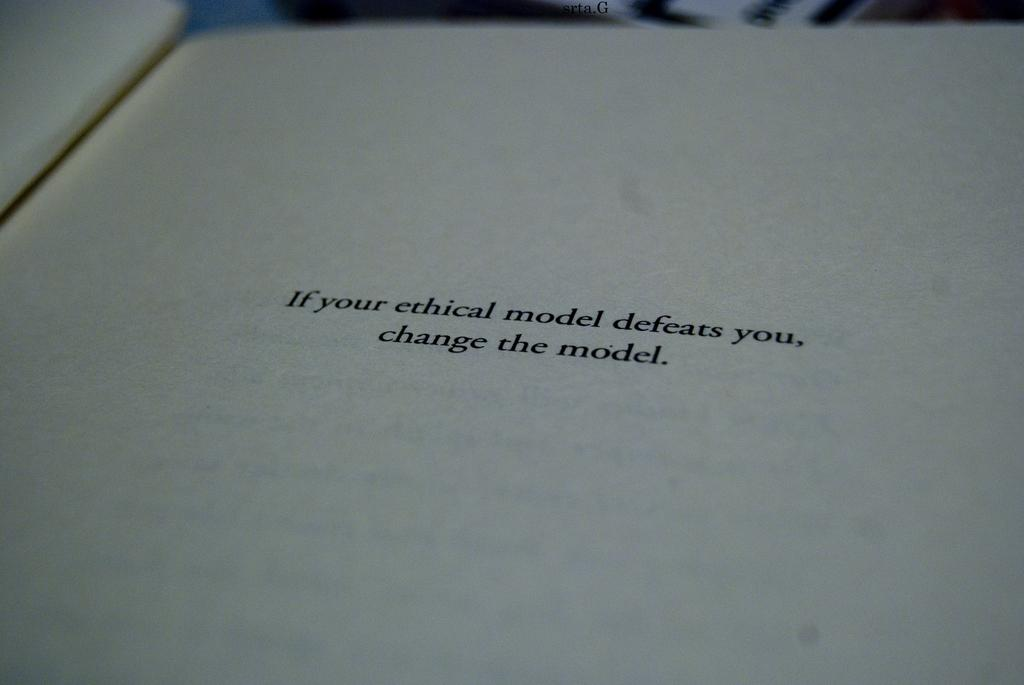<image>
Summarize the visual content of the image. A book is open to a page reading "If your ethical model defeats you, change the model." 